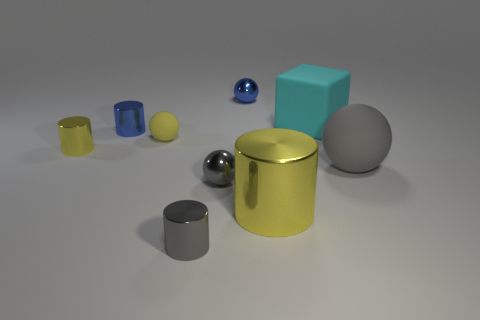Subtract all large cylinders. How many cylinders are left? 3 Subtract all spheres. How many objects are left? 5 Subtract 2 balls. How many balls are left? 2 Add 8 small gray objects. How many small gray objects exist? 10 Add 1 small blue metal things. How many objects exist? 10 Subtract all yellow spheres. How many spheres are left? 3 Subtract 0 green cylinders. How many objects are left? 9 Subtract all cyan spheres. Subtract all purple blocks. How many spheres are left? 4 Subtract all brown cylinders. How many yellow balls are left? 1 Subtract all gray balls. Subtract all tiny red shiny objects. How many objects are left? 7 